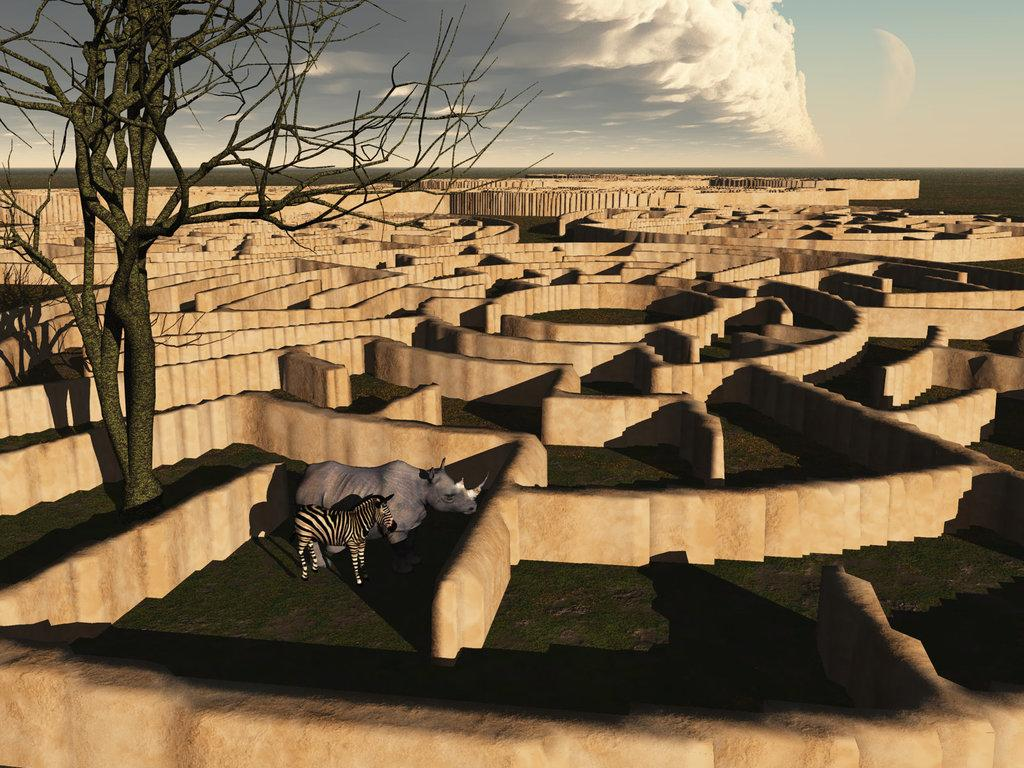What type of image is being described? The image is animated. What animals are present in the image? There is a zebra and a rhino in the image. Where are the zebra and rhino located in the image? The zebra and rhino are inside wall structures. What can be seen on the left side of the image? There is a tree on the left side of the image. What is visible in the background of the image? The sky is visible in the background of the image. What is the smell of the zebra in the image? There is no information about the smell of the zebra in the image, as it is an animated image and does not have a smell. 